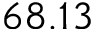<formula> <loc_0><loc_0><loc_500><loc_500>6 8 . 1 3</formula> 